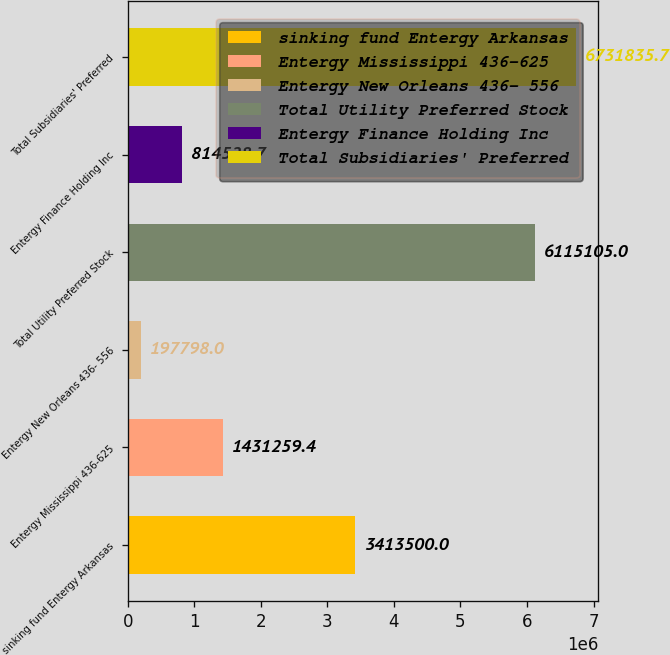Convert chart to OTSL. <chart><loc_0><loc_0><loc_500><loc_500><bar_chart><fcel>sinking fund Entergy Arkansas<fcel>Entergy Mississippi 436-625<fcel>Entergy New Orleans 436- 556<fcel>Total Utility Preferred Stock<fcel>Entergy Finance Holding Inc<fcel>Total Subsidiaries' Preferred<nl><fcel>3.4135e+06<fcel>1.43126e+06<fcel>197798<fcel>6.1151e+06<fcel>814529<fcel>6.73184e+06<nl></chart> 